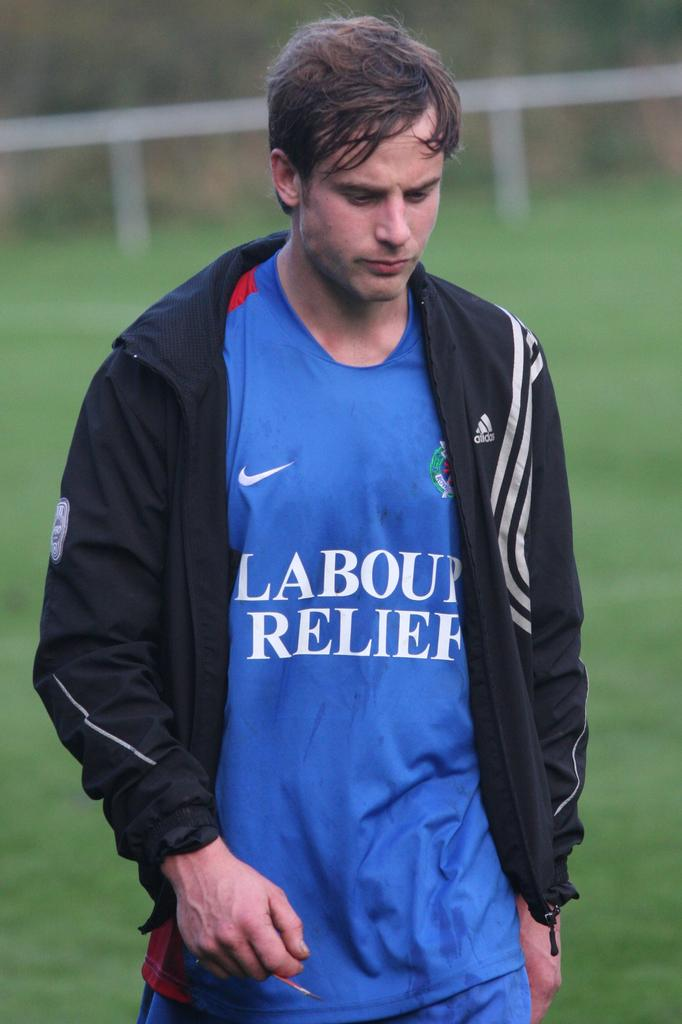<image>
Render a clear and concise summary of the photo. A white gentleman wearing a sporty adidas jacket over a blue shirt. 